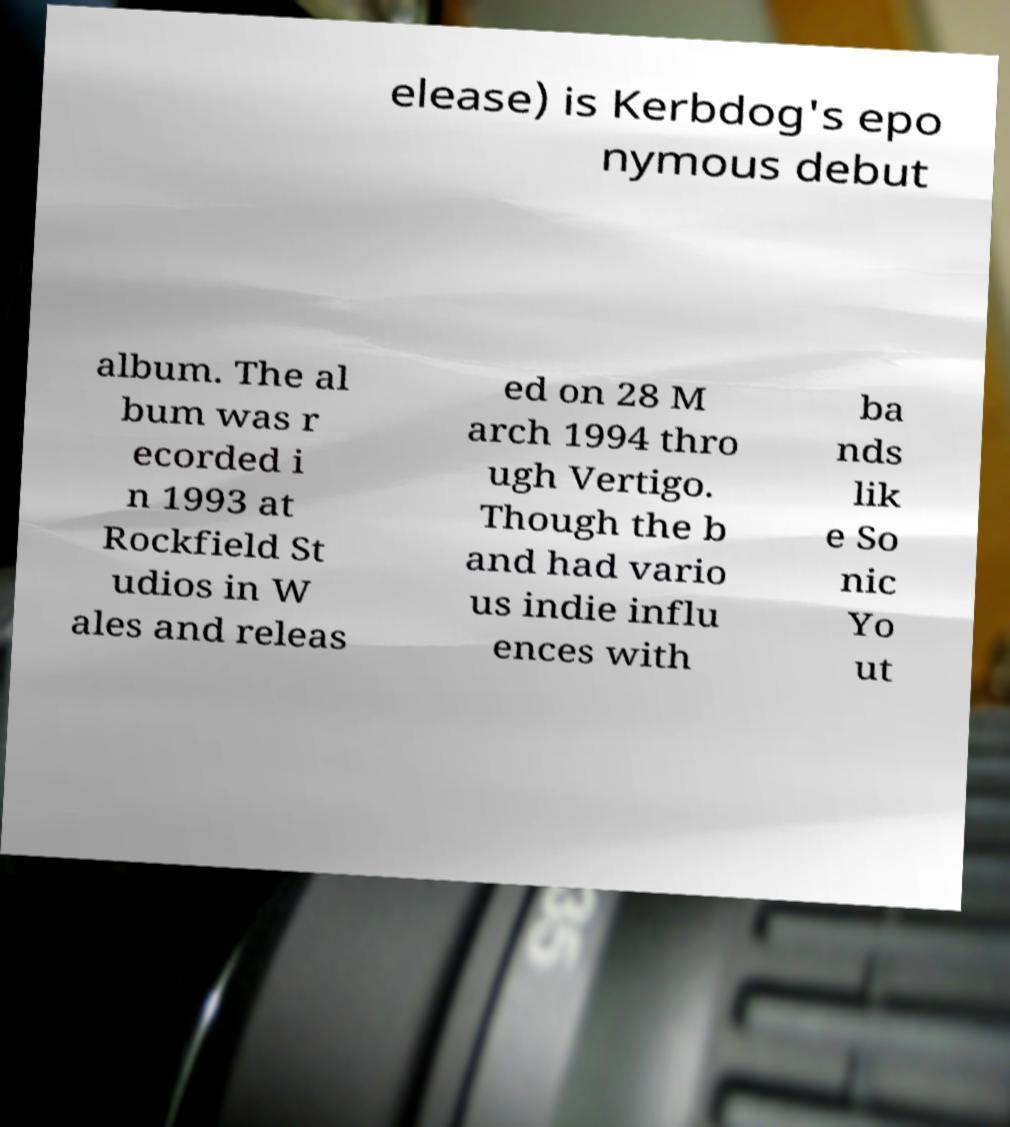Can you read and provide the text displayed in the image?This photo seems to have some interesting text. Can you extract and type it out for me? elease) is Kerbdog's epo nymous debut album. The al bum was r ecorded i n 1993 at Rockfield St udios in W ales and releas ed on 28 M arch 1994 thro ugh Vertigo. Though the b and had vario us indie influ ences with ba nds lik e So nic Yo ut 